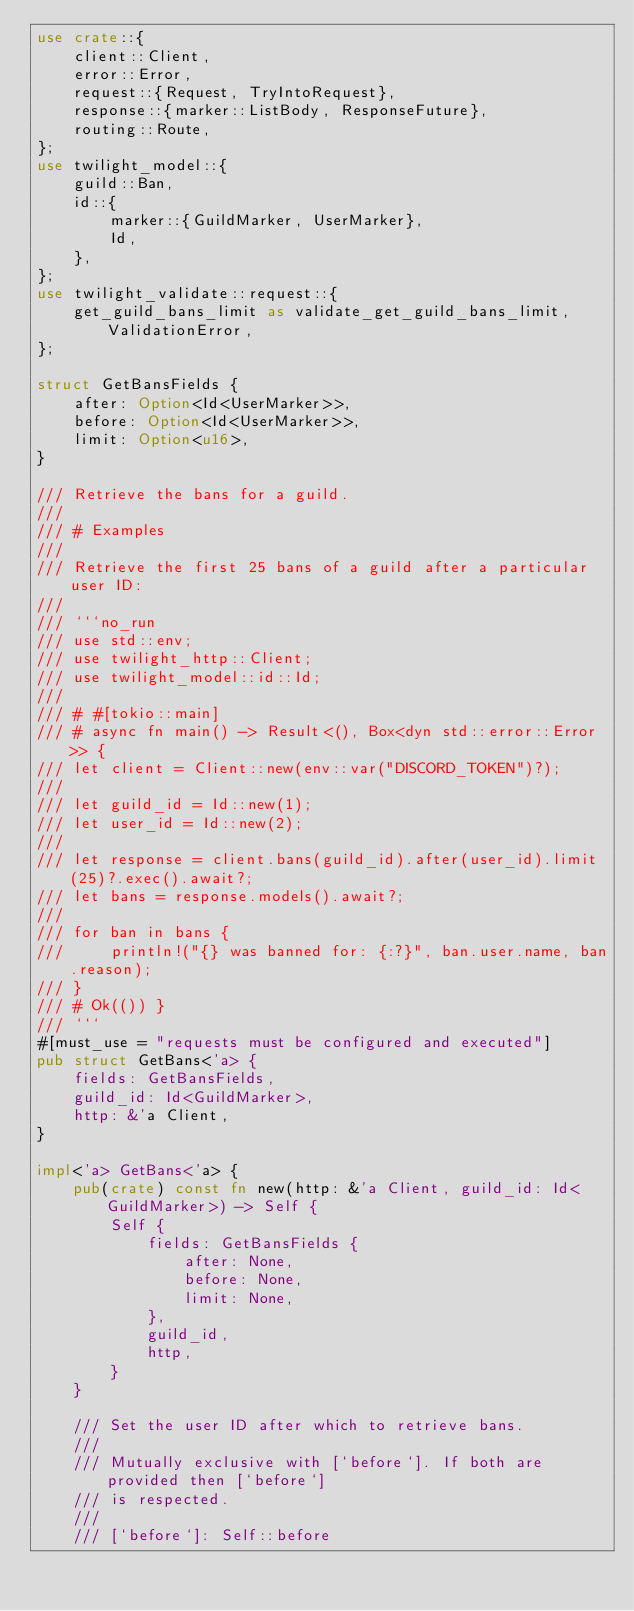Convert code to text. <code><loc_0><loc_0><loc_500><loc_500><_Rust_>use crate::{
    client::Client,
    error::Error,
    request::{Request, TryIntoRequest},
    response::{marker::ListBody, ResponseFuture},
    routing::Route,
};
use twilight_model::{
    guild::Ban,
    id::{
        marker::{GuildMarker, UserMarker},
        Id,
    },
};
use twilight_validate::request::{
    get_guild_bans_limit as validate_get_guild_bans_limit, ValidationError,
};

struct GetBansFields {
    after: Option<Id<UserMarker>>,
    before: Option<Id<UserMarker>>,
    limit: Option<u16>,
}

/// Retrieve the bans for a guild.
///
/// # Examples
///
/// Retrieve the first 25 bans of a guild after a particular user ID:
///
/// ```no_run
/// use std::env;
/// use twilight_http::Client;
/// use twilight_model::id::Id;
///
/// # #[tokio::main]
/// # async fn main() -> Result<(), Box<dyn std::error::Error>> {
/// let client = Client::new(env::var("DISCORD_TOKEN")?);
///
/// let guild_id = Id::new(1);
/// let user_id = Id::new(2);
///
/// let response = client.bans(guild_id).after(user_id).limit(25)?.exec().await?;
/// let bans = response.models().await?;
///
/// for ban in bans {
///     println!("{} was banned for: {:?}", ban.user.name, ban.reason);
/// }
/// # Ok(()) }
/// ```
#[must_use = "requests must be configured and executed"]
pub struct GetBans<'a> {
    fields: GetBansFields,
    guild_id: Id<GuildMarker>,
    http: &'a Client,
}

impl<'a> GetBans<'a> {
    pub(crate) const fn new(http: &'a Client, guild_id: Id<GuildMarker>) -> Self {
        Self {
            fields: GetBansFields {
                after: None,
                before: None,
                limit: None,
            },
            guild_id,
            http,
        }
    }

    /// Set the user ID after which to retrieve bans.
    ///
    /// Mutually exclusive with [`before`]. If both are provided then [`before`]
    /// is respected.
    ///
    /// [`before`]: Self::before</code> 